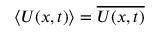Convert formula to latex. <formula><loc_0><loc_0><loc_500><loc_500>\langle U ( x , t ) \rangle = \overline { U ( x , t ) }</formula> 